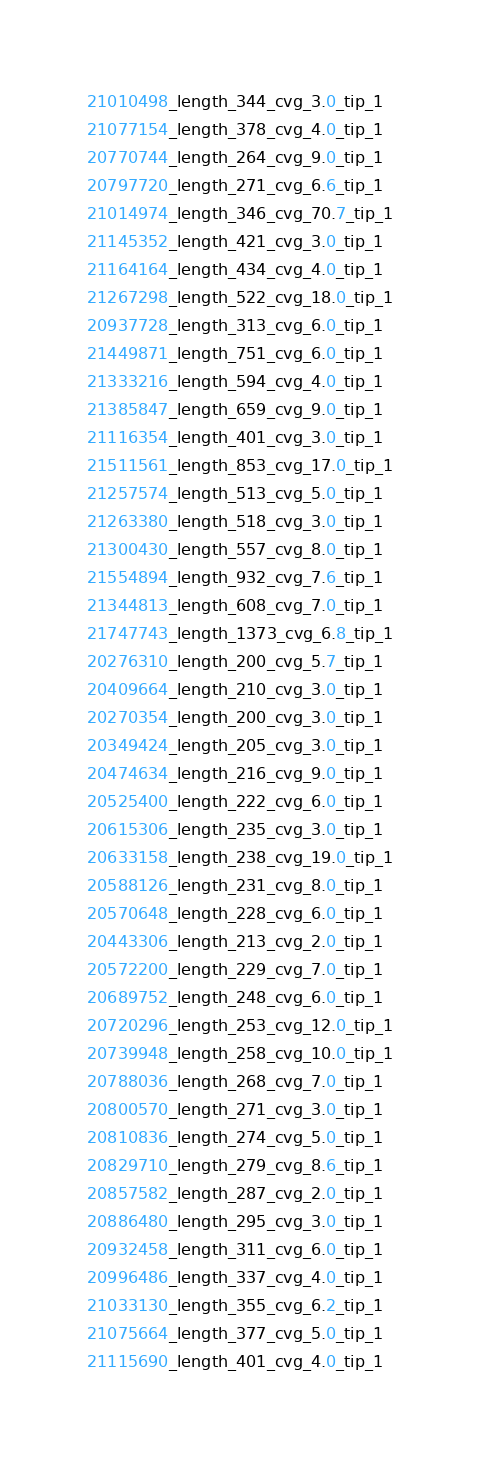Convert code to text. <code><loc_0><loc_0><loc_500><loc_500><_SQL_>21010498_length_344_cvg_3.0_tip_1
21077154_length_378_cvg_4.0_tip_1
20770744_length_264_cvg_9.0_tip_1
20797720_length_271_cvg_6.6_tip_1
21014974_length_346_cvg_70.7_tip_1
21145352_length_421_cvg_3.0_tip_1
21164164_length_434_cvg_4.0_tip_1
21267298_length_522_cvg_18.0_tip_1
20937728_length_313_cvg_6.0_tip_1
21449871_length_751_cvg_6.0_tip_1
21333216_length_594_cvg_4.0_tip_1
21385847_length_659_cvg_9.0_tip_1
21116354_length_401_cvg_3.0_tip_1
21511561_length_853_cvg_17.0_tip_1
21257574_length_513_cvg_5.0_tip_1
21263380_length_518_cvg_3.0_tip_1
21300430_length_557_cvg_8.0_tip_1
21554894_length_932_cvg_7.6_tip_1
21344813_length_608_cvg_7.0_tip_1
21747743_length_1373_cvg_6.8_tip_1
20276310_length_200_cvg_5.7_tip_1
20409664_length_210_cvg_3.0_tip_1
20270354_length_200_cvg_3.0_tip_1
20349424_length_205_cvg_3.0_tip_1
20474634_length_216_cvg_9.0_tip_1
20525400_length_222_cvg_6.0_tip_1
20615306_length_235_cvg_3.0_tip_1
20633158_length_238_cvg_19.0_tip_1
20588126_length_231_cvg_8.0_tip_1
20570648_length_228_cvg_6.0_tip_1
20443306_length_213_cvg_2.0_tip_1
20572200_length_229_cvg_7.0_tip_1
20689752_length_248_cvg_6.0_tip_1
20720296_length_253_cvg_12.0_tip_1
20739948_length_258_cvg_10.0_tip_1
20788036_length_268_cvg_7.0_tip_1
20800570_length_271_cvg_3.0_tip_1
20810836_length_274_cvg_5.0_tip_1
20829710_length_279_cvg_8.6_tip_1
20857582_length_287_cvg_2.0_tip_1
20886480_length_295_cvg_3.0_tip_1
20932458_length_311_cvg_6.0_tip_1
20996486_length_337_cvg_4.0_tip_1
21033130_length_355_cvg_6.2_tip_1
21075664_length_377_cvg_5.0_tip_1
21115690_length_401_cvg_4.0_tip_1</code> 